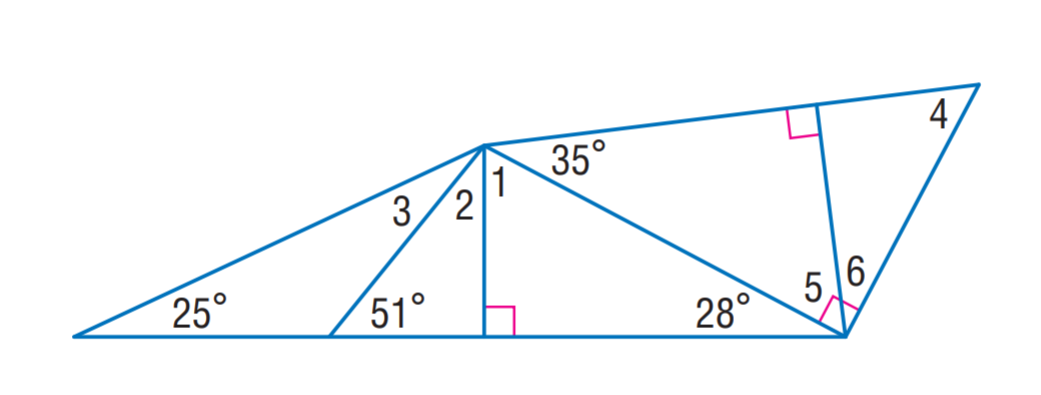Answer the mathemtical geometry problem and directly provide the correct option letter.
Question: Find m \angle 5.
Choices: A: 35 B: 39 C: 55 D: 62 C 